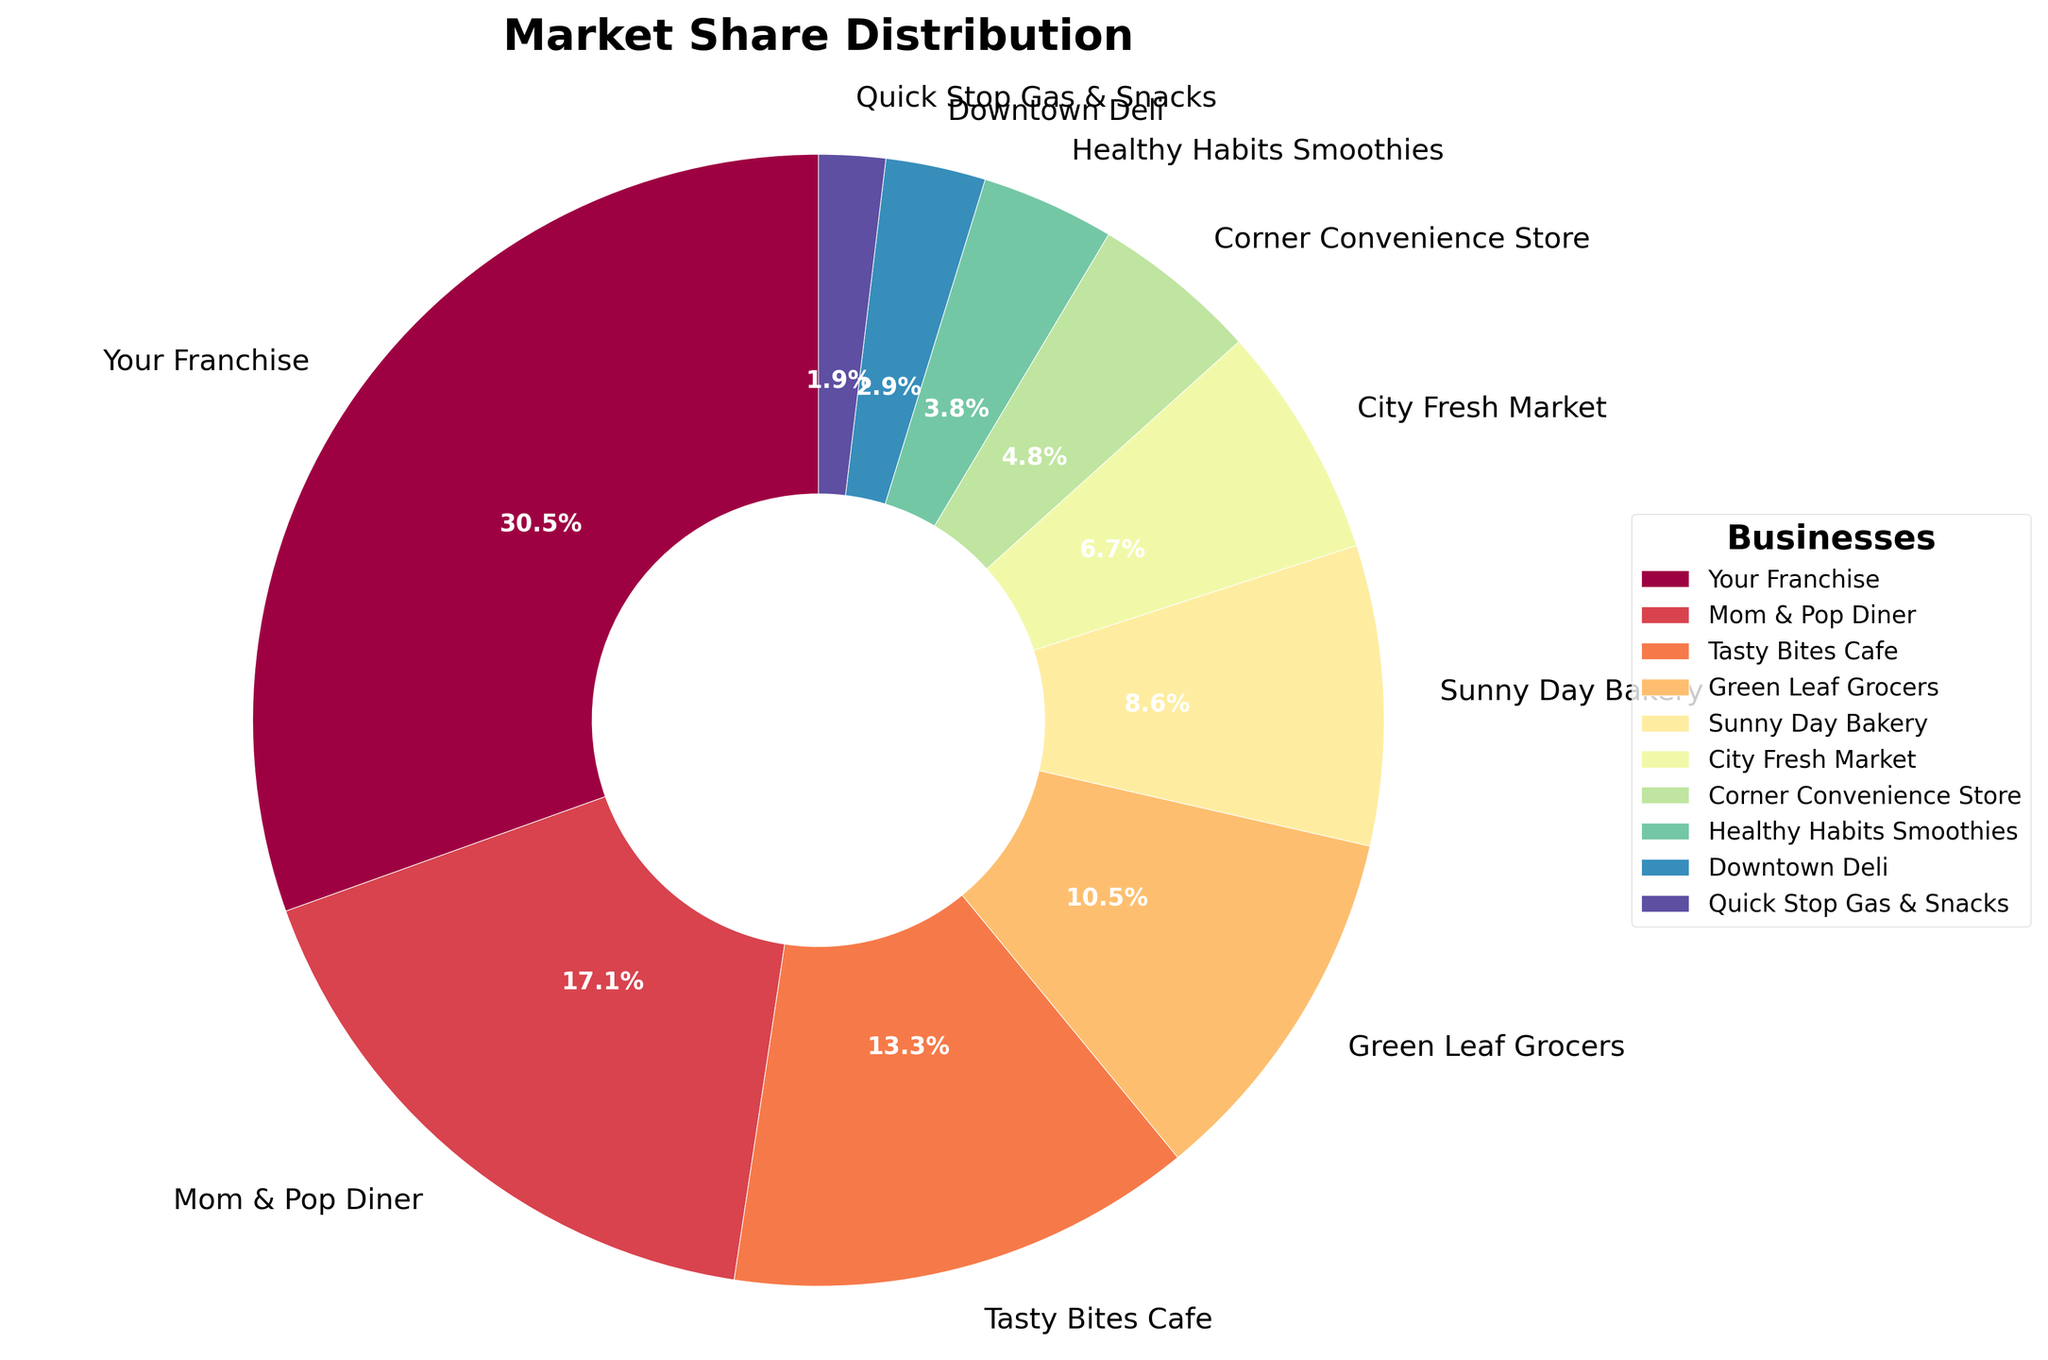What is the market share percentage of 'Your Franchise'? Look at the segment labeled 'Your Franchise' in the pie chart, which indicates a market share of 32%.
Answer: 32% Which business has the smallest market share? Locate the smallest segment in the pie chart which is labeled as 'Quick Stop Gas & Snacks' with 2%.
Answer: Quick Stop Gas & Snacks How does the market share of 'Your Franchise' compare to 'Mom & Pop Diner'? Identify the segments for 'Your Franchise' and 'Mom & Pop Diner' in the pie chart; 'Your Franchise' has 32% while 'Mom & Pop Diner' has 18%.
Answer: 'Your Franchise' has a higher market share What is the combined market share of 'Tasty Bites Cafe' and 'Green Leaf Grocers'? Add the market share percentages of 'Tasty Bites Cafe' (14%) and 'Green Leaf Grocers' (11%). 14% + 11% = 25%
Answer: 25% Which business has a larger market share: 'Sunny Day Bakery' or 'City Fresh Market'? Compare the segments for 'Sunny Day Bakery' which is 9% and 'City Fresh Market' which is 7%.
Answer: 'Sunny Day Bakery' What is the difference in market share between 'Corner Convenience Store' and 'Healthy Habits Smoothies'? Subtract the market share percentage of 'Healthy Habits Smoothies' (4%) from 'Corner Convenience Store' (5%). 5% - 4% = 1%
Answer: 1% Which business has a market share closest to 10%? Look at the pie chart and identify the segment closest to 10%, which is 'Sunny Day Bakery' with 9%.
Answer: Sunny Day Bakery What is the total market share of businesses with less than 5%? Add the market share percentages of businesses with less than 5%: 'Healthy Habits Smoothies' (4%), 'Downtown Deli' (3%), and 'Quick Stop Gas & Snacks' (2%). 4% + 3% + 2% = 9%
Answer: 9% In what order do the businesses appear in terms of decreasing market share? List the businesses starting from the largest segment to the smallest in the pie chart: 'Your Franchise' (32%), 'Mom & Pop Diner' (18%), 'Tasty Bites Cafe' (14%), 'Green Leaf Grocers' (11%), 'Sunny Day Bakery' (9%), 'City Fresh Market' (7%), 'Corner Convenience Store' (5%), 'Healthy Habits Smoothies' (4%), 'Downtown Deli' (3%), 'Quick Stop Gas & Snacks' (2%).
Answer: Your Franchise, Mom & Pop Diner, Tasty Bites Cafe, Green Leaf Grocers, Sunny Day Bakery, City Fresh Market, Corner Convenience Store, Healthy Habits Smoothies, Downtown Deli, Quick Stop Gas & Snacks 